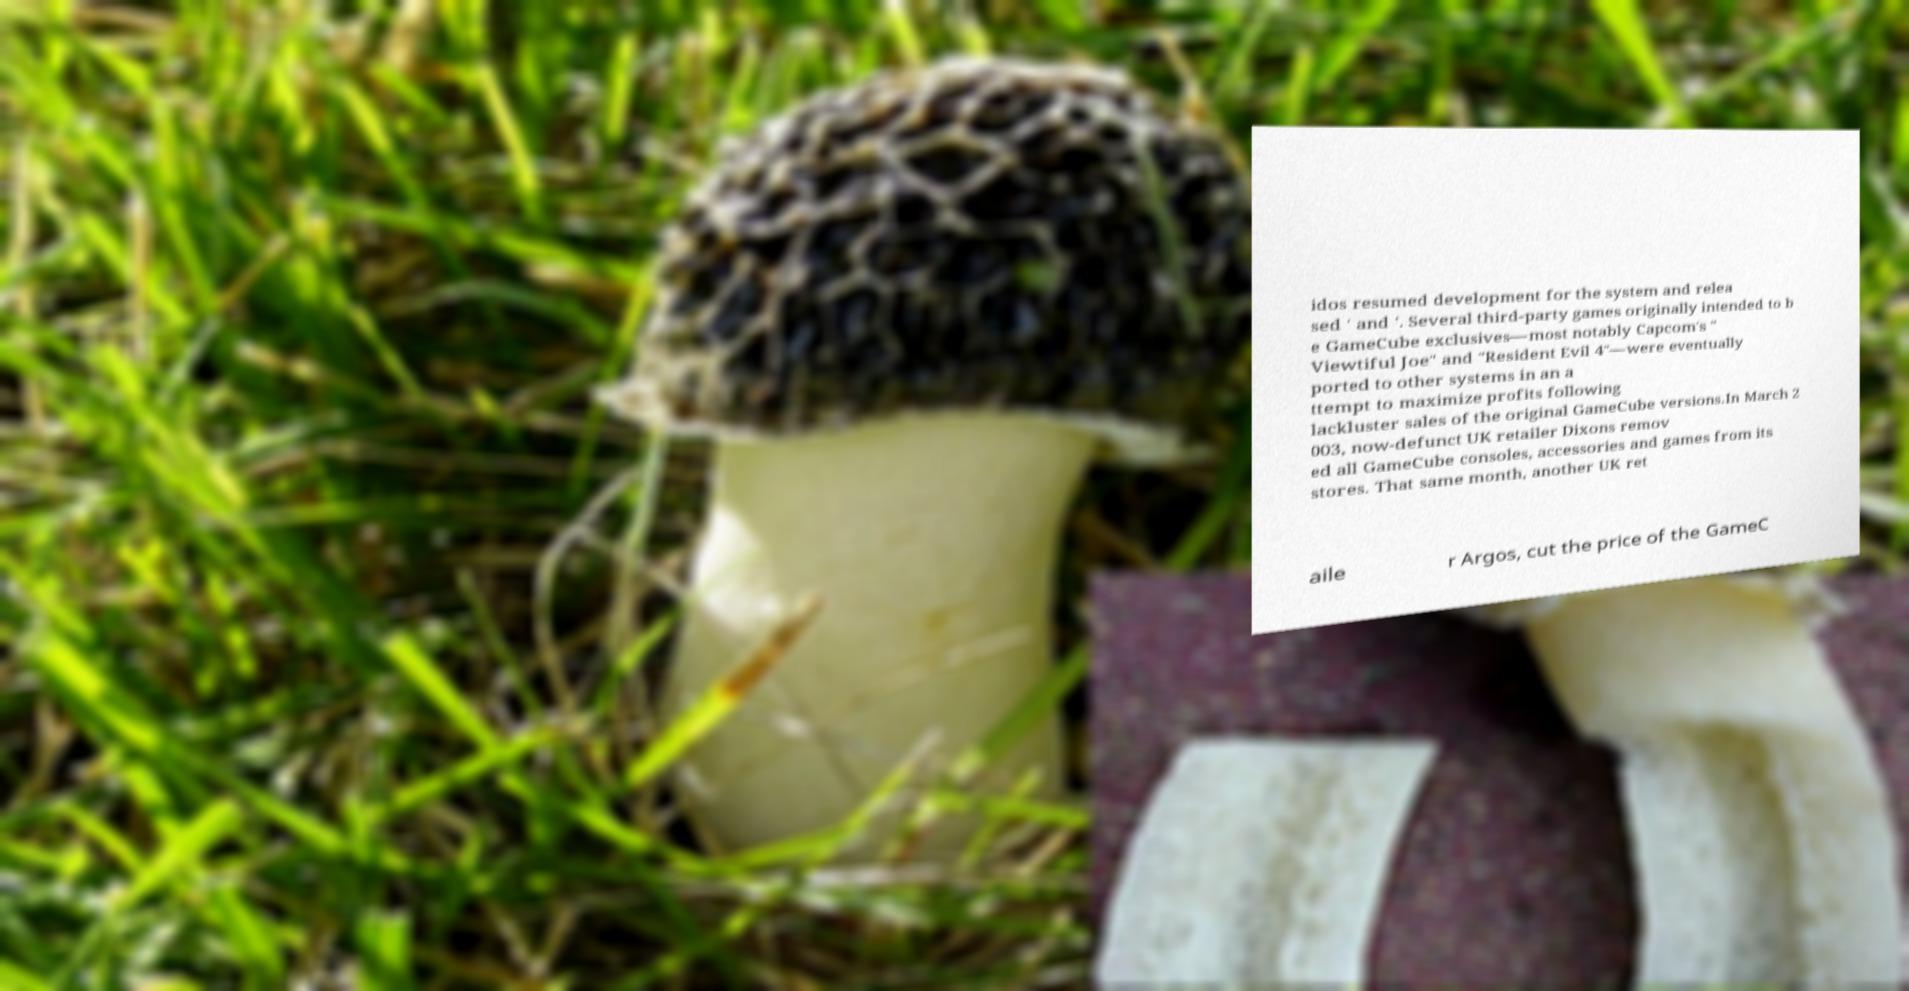For documentation purposes, I need the text within this image transcribed. Could you provide that? idos resumed development for the system and relea sed ' and '. Several third-party games originally intended to b e GameCube exclusives—most notably Capcom's " Viewtiful Joe" and "Resident Evil 4"—were eventually ported to other systems in an a ttempt to maximize profits following lackluster sales of the original GameCube versions.In March 2 003, now-defunct UK retailer Dixons remov ed all GameCube consoles, accessories and games from its stores. That same month, another UK ret aile r Argos, cut the price of the GameC 